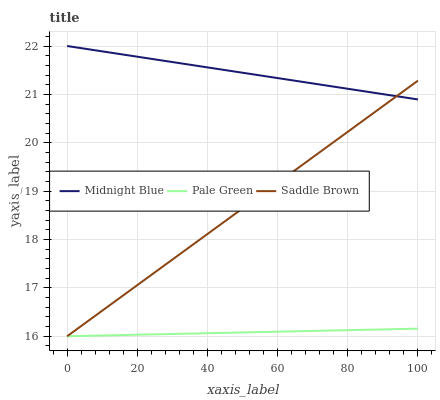Does Pale Green have the minimum area under the curve?
Answer yes or no. Yes. Does Midnight Blue have the maximum area under the curve?
Answer yes or no. Yes. Does Saddle Brown have the minimum area under the curve?
Answer yes or no. No. Does Saddle Brown have the maximum area under the curve?
Answer yes or no. No. Is Saddle Brown the smoothest?
Answer yes or no. Yes. Is Midnight Blue the roughest?
Answer yes or no. Yes. Is Midnight Blue the smoothest?
Answer yes or no. No. Is Saddle Brown the roughest?
Answer yes or no. No. Does Pale Green have the lowest value?
Answer yes or no. Yes. Does Midnight Blue have the lowest value?
Answer yes or no. No. Does Midnight Blue have the highest value?
Answer yes or no. Yes. Does Saddle Brown have the highest value?
Answer yes or no. No. Is Pale Green less than Midnight Blue?
Answer yes or no. Yes. Is Midnight Blue greater than Pale Green?
Answer yes or no. Yes. Does Pale Green intersect Saddle Brown?
Answer yes or no. Yes. Is Pale Green less than Saddle Brown?
Answer yes or no. No. Is Pale Green greater than Saddle Brown?
Answer yes or no. No. Does Pale Green intersect Midnight Blue?
Answer yes or no. No. 